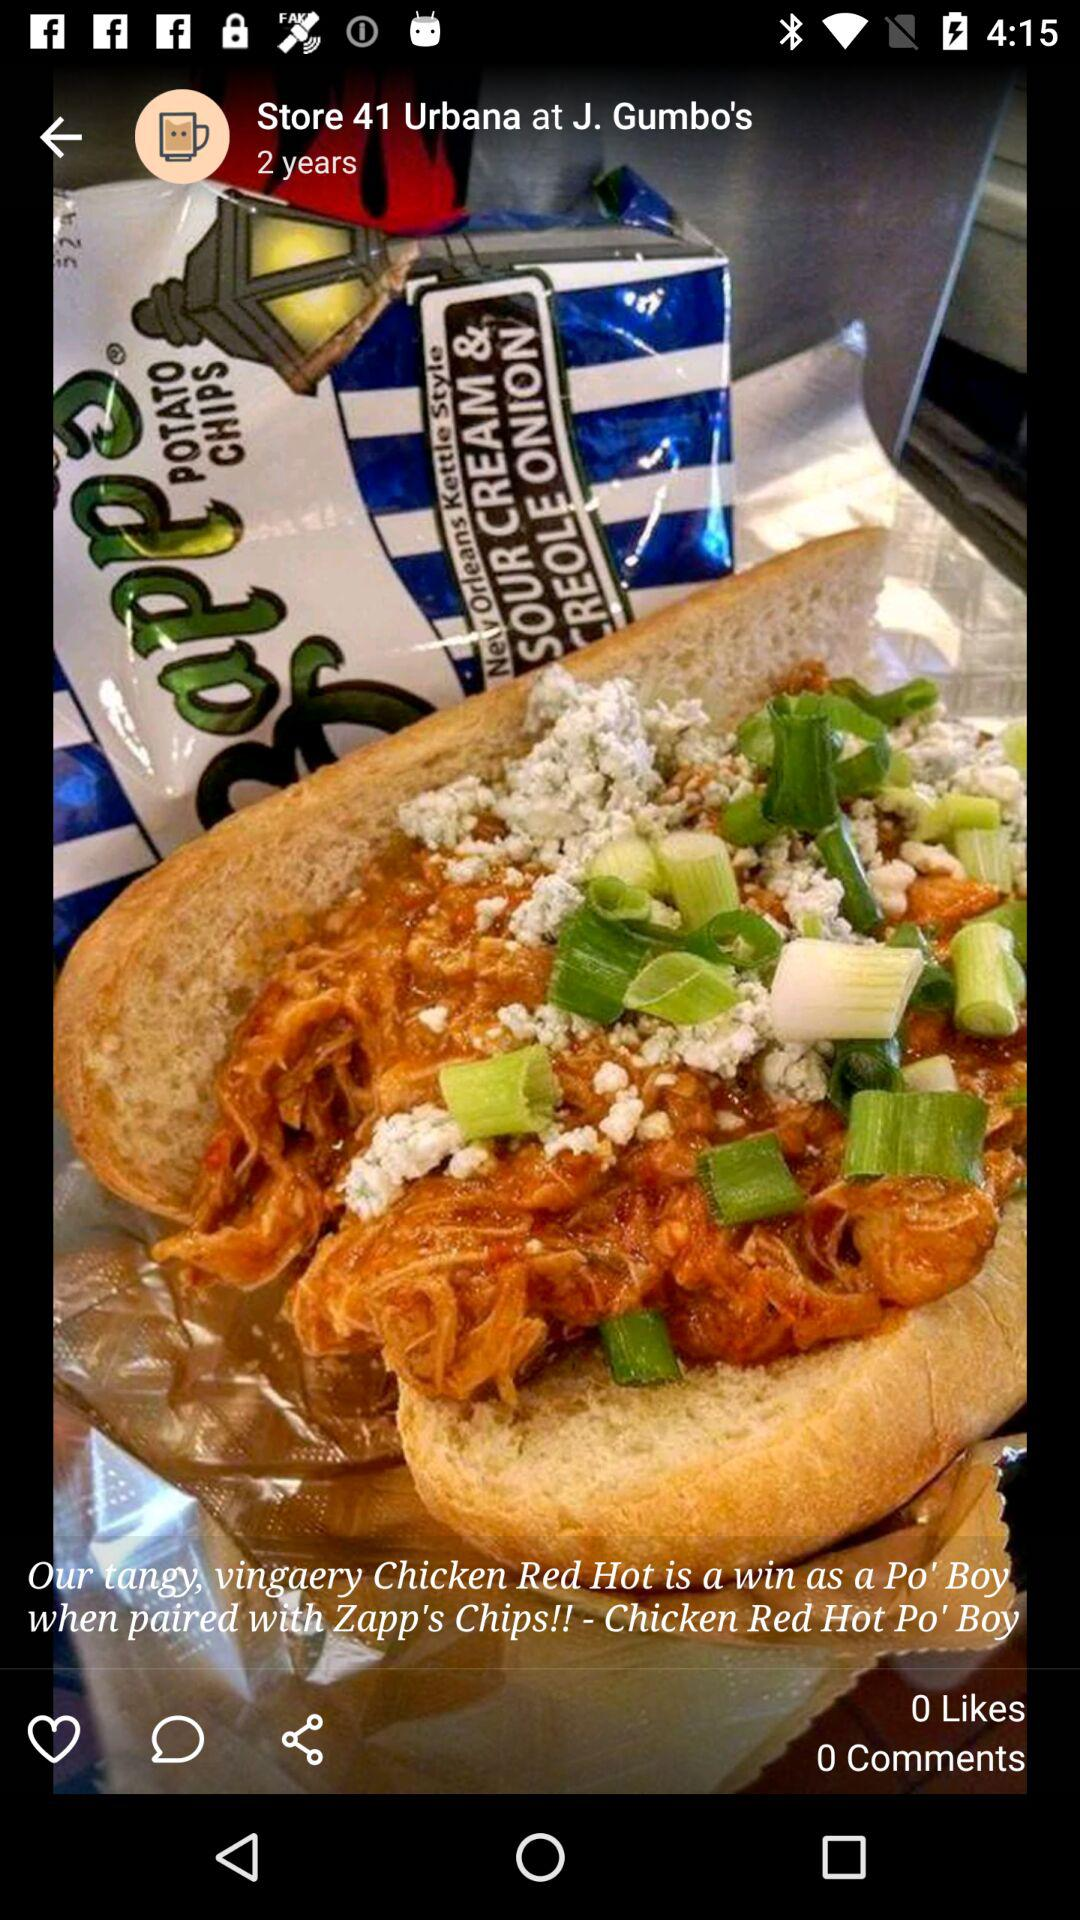How many more likes does the post have than comments?
Answer the question using a single word or phrase. 0 